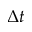<formula> <loc_0><loc_0><loc_500><loc_500>\Delta t</formula> 